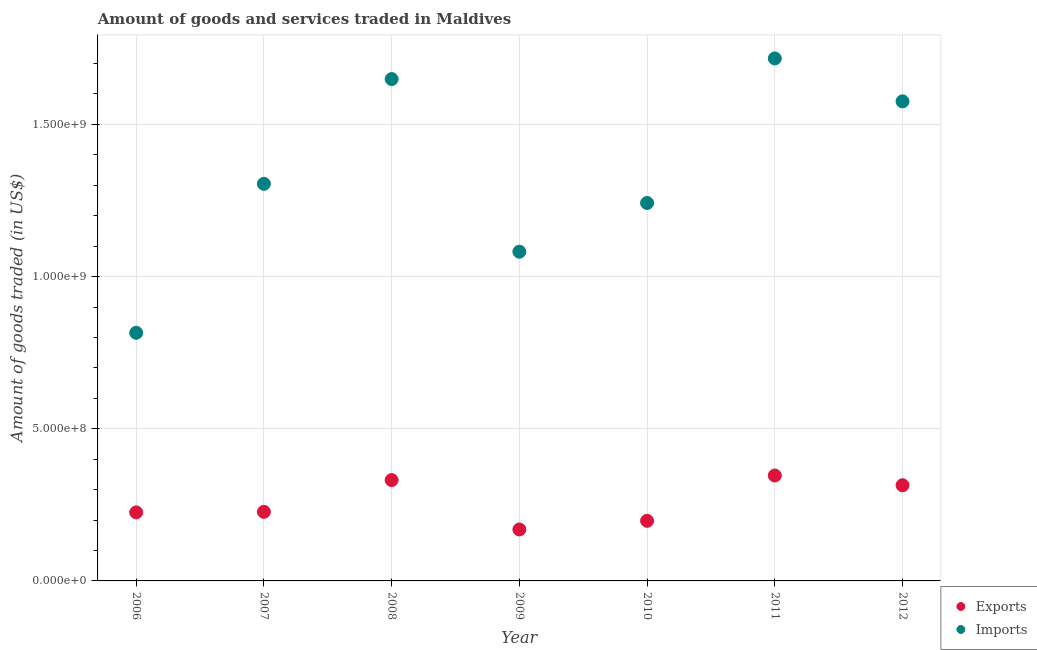How many different coloured dotlines are there?
Provide a short and direct response. 2. What is the amount of goods imported in 2009?
Provide a short and direct response. 1.08e+09. Across all years, what is the maximum amount of goods imported?
Make the answer very short. 1.72e+09. Across all years, what is the minimum amount of goods exported?
Offer a very short reply. 1.69e+08. In which year was the amount of goods imported minimum?
Your answer should be very brief. 2006. What is the total amount of goods imported in the graph?
Offer a very short reply. 9.39e+09. What is the difference between the amount of goods exported in 2006 and that in 2011?
Ensure brevity in your answer.  -1.21e+08. What is the difference between the amount of goods exported in 2010 and the amount of goods imported in 2008?
Ensure brevity in your answer.  -1.45e+09. What is the average amount of goods exported per year?
Your answer should be very brief. 2.59e+08. In the year 2007, what is the difference between the amount of goods exported and amount of goods imported?
Give a very brief answer. -1.08e+09. What is the ratio of the amount of goods imported in 2008 to that in 2012?
Give a very brief answer. 1.05. Is the amount of goods imported in 2007 less than that in 2010?
Ensure brevity in your answer.  No. Is the difference between the amount of goods imported in 2006 and 2008 greater than the difference between the amount of goods exported in 2006 and 2008?
Give a very brief answer. No. What is the difference between the highest and the second highest amount of goods exported?
Provide a short and direct response. 1.50e+07. What is the difference between the highest and the lowest amount of goods imported?
Ensure brevity in your answer.  9.01e+08. Is the sum of the amount of goods imported in 2006 and 2007 greater than the maximum amount of goods exported across all years?
Offer a terse response. Yes. Is the amount of goods imported strictly less than the amount of goods exported over the years?
Provide a short and direct response. No. How many dotlines are there?
Your response must be concise. 2. How many years are there in the graph?
Make the answer very short. 7. Are the values on the major ticks of Y-axis written in scientific E-notation?
Ensure brevity in your answer.  Yes. Does the graph contain any zero values?
Make the answer very short. No. Does the graph contain grids?
Your answer should be very brief. Yes. Where does the legend appear in the graph?
Your response must be concise. Bottom right. How many legend labels are there?
Your answer should be compact. 2. How are the legend labels stacked?
Offer a terse response. Vertical. What is the title of the graph?
Offer a terse response. Amount of goods and services traded in Maldives. Does "Male entrants" appear as one of the legend labels in the graph?
Offer a terse response. No. What is the label or title of the Y-axis?
Provide a short and direct response. Amount of goods traded (in US$). What is the Amount of goods traded (in US$) of Exports in 2006?
Provide a succinct answer. 2.25e+08. What is the Amount of goods traded (in US$) of Imports in 2006?
Make the answer very short. 8.15e+08. What is the Amount of goods traded (in US$) of Exports in 2007?
Your response must be concise. 2.27e+08. What is the Amount of goods traded (in US$) of Imports in 2007?
Give a very brief answer. 1.30e+09. What is the Amount of goods traded (in US$) in Exports in 2008?
Keep it short and to the point. 3.31e+08. What is the Amount of goods traded (in US$) of Imports in 2008?
Your answer should be compact. 1.65e+09. What is the Amount of goods traded (in US$) of Exports in 2009?
Provide a succinct answer. 1.69e+08. What is the Amount of goods traded (in US$) of Imports in 2009?
Offer a terse response. 1.08e+09. What is the Amount of goods traded (in US$) in Exports in 2010?
Provide a short and direct response. 1.98e+08. What is the Amount of goods traded (in US$) of Imports in 2010?
Ensure brevity in your answer.  1.24e+09. What is the Amount of goods traded (in US$) in Exports in 2011?
Your answer should be very brief. 3.46e+08. What is the Amount of goods traded (in US$) in Imports in 2011?
Provide a short and direct response. 1.72e+09. What is the Amount of goods traded (in US$) of Exports in 2012?
Provide a short and direct response. 3.14e+08. What is the Amount of goods traded (in US$) of Imports in 2012?
Provide a short and direct response. 1.58e+09. Across all years, what is the maximum Amount of goods traded (in US$) of Exports?
Keep it short and to the point. 3.46e+08. Across all years, what is the maximum Amount of goods traded (in US$) in Imports?
Provide a short and direct response. 1.72e+09. Across all years, what is the minimum Amount of goods traded (in US$) in Exports?
Your response must be concise. 1.69e+08. Across all years, what is the minimum Amount of goods traded (in US$) in Imports?
Ensure brevity in your answer.  8.15e+08. What is the total Amount of goods traded (in US$) in Exports in the graph?
Ensure brevity in your answer.  1.81e+09. What is the total Amount of goods traded (in US$) in Imports in the graph?
Your answer should be very brief. 9.39e+09. What is the difference between the Amount of goods traded (in US$) in Exports in 2006 and that in 2007?
Your answer should be very brief. -1.71e+06. What is the difference between the Amount of goods traded (in US$) in Imports in 2006 and that in 2007?
Your response must be concise. -4.89e+08. What is the difference between the Amount of goods traded (in US$) in Exports in 2006 and that in 2008?
Offer a very short reply. -1.06e+08. What is the difference between the Amount of goods traded (in US$) of Imports in 2006 and that in 2008?
Ensure brevity in your answer.  -8.34e+08. What is the difference between the Amount of goods traded (in US$) of Exports in 2006 and that in 2009?
Offer a very short reply. 5.62e+07. What is the difference between the Amount of goods traded (in US$) of Imports in 2006 and that in 2009?
Provide a short and direct response. -2.66e+08. What is the difference between the Amount of goods traded (in US$) of Exports in 2006 and that in 2010?
Offer a terse response. 2.77e+07. What is the difference between the Amount of goods traded (in US$) of Imports in 2006 and that in 2010?
Provide a succinct answer. -4.26e+08. What is the difference between the Amount of goods traded (in US$) of Exports in 2006 and that in 2011?
Keep it short and to the point. -1.21e+08. What is the difference between the Amount of goods traded (in US$) in Imports in 2006 and that in 2011?
Your answer should be compact. -9.01e+08. What is the difference between the Amount of goods traded (in US$) in Exports in 2006 and that in 2012?
Make the answer very short. -8.92e+07. What is the difference between the Amount of goods traded (in US$) of Imports in 2006 and that in 2012?
Provide a short and direct response. -7.60e+08. What is the difference between the Amount of goods traded (in US$) in Exports in 2007 and that in 2008?
Your response must be concise. -1.04e+08. What is the difference between the Amount of goods traded (in US$) in Imports in 2007 and that in 2008?
Your response must be concise. -3.44e+08. What is the difference between the Amount of goods traded (in US$) in Exports in 2007 and that in 2009?
Keep it short and to the point. 5.79e+07. What is the difference between the Amount of goods traded (in US$) in Imports in 2007 and that in 2009?
Offer a very short reply. 2.23e+08. What is the difference between the Amount of goods traded (in US$) in Exports in 2007 and that in 2010?
Offer a very short reply. 2.95e+07. What is the difference between the Amount of goods traded (in US$) in Imports in 2007 and that in 2010?
Offer a terse response. 6.30e+07. What is the difference between the Amount of goods traded (in US$) of Exports in 2007 and that in 2011?
Your answer should be compact. -1.19e+08. What is the difference between the Amount of goods traded (in US$) of Imports in 2007 and that in 2011?
Keep it short and to the point. -4.12e+08. What is the difference between the Amount of goods traded (in US$) in Exports in 2007 and that in 2012?
Your answer should be compact. -8.75e+07. What is the difference between the Amount of goods traded (in US$) in Imports in 2007 and that in 2012?
Your response must be concise. -2.71e+08. What is the difference between the Amount of goods traded (in US$) of Exports in 2008 and that in 2009?
Offer a terse response. 1.62e+08. What is the difference between the Amount of goods traded (in US$) of Imports in 2008 and that in 2009?
Give a very brief answer. 5.67e+08. What is the difference between the Amount of goods traded (in US$) in Exports in 2008 and that in 2010?
Offer a very short reply. 1.34e+08. What is the difference between the Amount of goods traded (in US$) of Imports in 2008 and that in 2010?
Give a very brief answer. 4.07e+08. What is the difference between the Amount of goods traded (in US$) of Exports in 2008 and that in 2011?
Offer a very short reply. -1.50e+07. What is the difference between the Amount of goods traded (in US$) in Imports in 2008 and that in 2011?
Provide a short and direct response. -6.78e+07. What is the difference between the Amount of goods traded (in US$) in Exports in 2008 and that in 2012?
Your answer should be compact. 1.70e+07. What is the difference between the Amount of goods traded (in US$) in Imports in 2008 and that in 2012?
Ensure brevity in your answer.  7.32e+07. What is the difference between the Amount of goods traded (in US$) in Exports in 2009 and that in 2010?
Ensure brevity in your answer.  -2.85e+07. What is the difference between the Amount of goods traded (in US$) of Imports in 2009 and that in 2010?
Make the answer very short. -1.60e+08. What is the difference between the Amount of goods traded (in US$) in Exports in 2009 and that in 2011?
Your answer should be very brief. -1.77e+08. What is the difference between the Amount of goods traded (in US$) of Imports in 2009 and that in 2011?
Give a very brief answer. -6.35e+08. What is the difference between the Amount of goods traded (in US$) in Exports in 2009 and that in 2012?
Offer a very short reply. -1.45e+08. What is the difference between the Amount of goods traded (in US$) in Imports in 2009 and that in 2012?
Keep it short and to the point. -4.94e+08. What is the difference between the Amount of goods traded (in US$) in Exports in 2010 and that in 2011?
Your answer should be very brief. -1.49e+08. What is the difference between the Amount of goods traded (in US$) of Imports in 2010 and that in 2011?
Offer a terse response. -4.75e+08. What is the difference between the Amount of goods traded (in US$) in Exports in 2010 and that in 2012?
Your answer should be compact. -1.17e+08. What is the difference between the Amount of goods traded (in US$) of Imports in 2010 and that in 2012?
Your answer should be compact. -3.34e+08. What is the difference between the Amount of goods traded (in US$) in Exports in 2011 and that in 2012?
Keep it short and to the point. 3.20e+07. What is the difference between the Amount of goods traded (in US$) in Imports in 2011 and that in 2012?
Offer a very short reply. 1.41e+08. What is the difference between the Amount of goods traded (in US$) of Exports in 2006 and the Amount of goods traded (in US$) of Imports in 2007?
Your answer should be very brief. -1.08e+09. What is the difference between the Amount of goods traded (in US$) of Exports in 2006 and the Amount of goods traded (in US$) of Imports in 2008?
Offer a terse response. -1.42e+09. What is the difference between the Amount of goods traded (in US$) of Exports in 2006 and the Amount of goods traded (in US$) of Imports in 2009?
Offer a very short reply. -8.56e+08. What is the difference between the Amount of goods traded (in US$) of Exports in 2006 and the Amount of goods traded (in US$) of Imports in 2010?
Your answer should be very brief. -1.02e+09. What is the difference between the Amount of goods traded (in US$) in Exports in 2006 and the Amount of goods traded (in US$) in Imports in 2011?
Make the answer very short. -1.49e+09. What is the difference between the Amount of goods traded (in US$) in Exports in 2006 and the Amount of goods traded (in US$) in Imports in 2012?
Your response must be concise. -1.35e+09. What is the difference between the Amount of goods traded (in US$) in Exports in 2007 and the Amount of goods traded (in US$) in Imports in 2008?
Give a very brief answer. -1.42e+09. What is the difference between the Amount of goods traded (in US$) in Exports in 2007 and the Amount of goods traded (in US$) in Imports in 2009?
Your answer should be very brief. -8.55e+08. What is the difference between the Amount of goods traded (in US$) in Exports in 2007 and the Amount of goods traded (in US$) in Imports in 2010?
Ensure brevity in your answer.  -1.01e+09. What is the difference between the Amount of goods traded (in US$) in Exports in 2007 and the Amount of goods traded (in US$) in Imports in 2011?
Your answer should be compact. -1.49e+09. What is the difference between the Amount of goods traded (in US$) of Exports in 2007 and the Amount of goods traded (in US$) of Imports in 2012?
Offer a very short reply. -1.35e+09. What is the difference between the Amount of goods traded (in US$) in Exports in 2008 and the Amount of goods traded (in US$) in Imports in 2009?
Keep it short and to the point. -7.50e+08. What is the difference between the Amount of goods traded (in US$) in Exports in 2008 and the Amount of goods traded (in US$) in Imports in 2010?
Ensure brevity in your answer.  -9.10e+08. What is the difference between the Amount of goods traded (in US$) of Exports in 2008 and the Amount of goods traded (in US$) of Imports in 2011?
Your answer should be compact. -1.39e+09. What is the difference between the Amount of goods traded (in US$) in Exports in 2008 and the Amount of goods traded (in US$) in Imports in 2012?
Keep it short and to the point. -1.24e+09. What is the difference between the Amount of goods traded (in US$) in Exports in 2009 and the Amount of goods traded (in US$) in Imports in 2010?
Ensure brevity in your answer.  -1.07e+09. What is the difference between the Amount of goods traded (in US$) of Exports in 2009 and the Amount of goods traded (in US$) of Imports in 2011?
Give a very brief answer. -1.55e+09. What is the difference between the Amount of goods traded (in US$) in Exports in 2009 and the Amount of goods traded (in US$) in Imports in 2012?
Give a very brief answer. -1.41e+09. What is the difference between the Amount of goods traded (in US$) of Exports in 2010 and the Amount of goods traded (in US$) of Imports in 2011?
Your response must be concise. -1.52e+09. What is the difference between the Amount of goods traded (in US$) of Exports in 2010 and the Amount of goods traded (in US$) of Imports in 2012?
Provide a succinct answer. -1.38e+09. What is the difference between the Amount of goods traded (in US$) of Exports in 2011 and the Amount of goods traded (in US$) of Imports in 2012?
Offer a terse response. -1.23e+09. What is the average Amount of goods traded (in US$) in Exports per year?
Offer a terse response. 2.59e+08. What is the average Amount of goods traded (in US$) in Imports per year?
Your answer should be compact. 1.34e+09. In the year 2006, what is the difference between the Amount of goods traded (in US$) of Exports and Amount of goods traded (in US$) of Imports?
Offer a very short reply. -5.90e+08. In the year 2007, what is the difference between the Amount of goods traded (in US$) in Exports and Amount of goods traded (in US$) in Imports?
Provide a succinct answer. -1.08e+09. In the year 2008, what is the difference between the Amount of goods traded (in US$) of Exports and Amount of goods traded (in US$) of Imports?
Offer a terse response. -1.32e+09. In the year 2009, what is the difference between the Amount of goods traded (in US$) in Exports and Amount of goods traded (in US$) in Imports?
Provide a succinct answer. -9.13e+08. In the year 2010, what is the difference between the Amount of goods traded (in US$) in Exports and Amount of goods traded (in US$) in Imports?
Provide a short and direct response. -1.04e+09. In the year 2011, what is the difference between the Amount of goods traded (in US$) in Exports and Amount of goods traded (in US$) in Imports?
Keep it short and to the point. -1.37e+09. In the year 2012, what is the difference between the Amount of goods traded (in US$) in Exports and Amount of goods traded (in US$) in Imports?
Offer a very short reply. -1.26e+09. What is the ratio of the Amount of goods traded (in US$) of Exports in 2006 to that in 2007?
Offer a terse response. 0.99. What is the ratio of the Amount of goods traded (in US$) of Imports in 2006 to that in 2007?
Offer a terse response. 0.62. What is the ratio of the Amount of goods traded (in US$) of Exports in 2006 to that in 2008?
Ensure brevity in your answer.  0.68. What is the ratio of the Amount of goods traded (in US$) of Imports in 2006 to that in 2008?
Make the answer very short. 0.49. What is the ratio of the Amount of goods traded (in US$) in Exports in 2006 to that in 2009?
Give a very brief answer. 1.33. What is the ratio of the Amount of goods traded (in US$) of Imports in 2006 to that in 2009?
Give a very brief answer. 0.75. What is the ratio of the Amount of goods traded (in US$) in Exports in 2006 to that in 2010?
Offer a terse response. 1.14. What is the ratio of the Amount of goods traded (in US$) in Imports in 2006 to that in 2010?
Your answer should be very brief. 0.66. What is the ratio of the Amount of goods traded (in US$) in Exports in 2006 to that in 2011?
Keep it short and to the point. 0.65. What is the ratio of the Amount of goods traded (in US$) in Imports in 2006 to that in 2011?
Give a very brief answer. 0.47. What is the ratio of the Amount of goods traded (in US$) of Exports in 2006 to that in 2012?
Give a very brief answer. 0.72. What is the ratio of the Amount of goods traded (in US$) in Imports in 2006 to that in 2012?
Your response must be concise. 0.52. What is the ratio of the Amount of goods traded (in US$) of Exports in 2007 to that in 2008?
Make the answer very short. 0.68. What is the ratio of the Amount of goods traded (in US$) of Imports in 2007 to that in 2008?
Ensure brevity in your answer.  0.79. What is the ratio of the Amount of goods traded (in US$) of Exports in 2007 to that in 2009?
Provide a short and direct response. 1.34. What is the ratio of the Amount of goods traded (in US$) of Imports in 2007 to that in 2009?
Offer a terse response. 1.21. What is the ratio of the Amount of goods traded (in US$) of Exports in 2007 to that in 2010?
Provide a succinct answer. 1.15. What is the ratio of the Amount of goods traded (in US$) in Imports in 2007 to that in 2010?
Offer a very short reply. 1.05. What is the ratio of the Amount of goods traded (in US$) of Exports in 2007 to that in 2011?
Ensure brevity in your answer.  0.66. What is the ratio of the Amount of goods traded (in US$) in Imports in 2007 to that in 2011?
Your answer should be very brief. 0.76. What is the ratio of the Amount of goods traded (in US$) in Exports in 2007 to that in 2012?
Your answer should be very brief. 0.72. What is the ratio of the Amount of goods traded (in US$) in Imports in 2007 to that in 2012?
Keep it short and to the point. 0.83. What is the ratio of the Amount of goods traded (in US$) in Exports in 2008 to that in 2009?
Offer a very short reply. 1.96. What is the ratio of the Amount of goods traded (in US$) of Imports in 2008 to that in 2009?
Your answer should be compact. 1.52. What is the ratio of the Amount of goods traded (in US$) of Exports in 2008 to that in 2010?
Ensure brevity in your answer.  1.68. What is the ratio of the Amount of goods traded (in US$) of Imports in 2008 to that in 2010?
Your answer should be compact. 1.33. What is the ratio of the Amount of goods traded (in US$) in Exports in 2008 to that in 2011?
Provide a short and direct response. 0.96. What is the ratio of the Amount of goods traded (in US$) in Imports in 2008 to that in 2011?
Offer a very short reply. 0.96. What is the ratio of the Amount of goods traded (in US$) in Exports in 2008 to that in 2012?
Make the answer very short. 1.05. What is the ratio of the Amount of goods traded (in US$) of Imports in 2008 to that in 2012?
Your answer should be very brief. 1.05. What is the ratio of the Amount of goods traded (in US$) in Exports in 2009 to that in 2010?
Keep it short and to the point. 0.86. What is the ratio of the Amount of goods traded (in US$) of Imports in 2009 to that in 2010?
Give a very brief answer. 0.87. What is the ratio of the Amount of goods traded (in US$) of Exports in 2009 to that in 2011?
Offer a very short reply. 0.49. What is the ratio of the Amount of goods traded (in US$) in Imports in 2009 to that in 2011?
Ensure brevity in your answer.  0.63. What is the ratio of the Amount of goods traded (in US$) in Exports in 2009 to that in 2012?
Your response must be concise. 0.54. What is the ratio of the Amount of goods traded (in US$) of Imports in 2009 to that in 2012?
Your response must be concise. 0.69. What is the ratio of the Amount of goods traded (in US$) of Exports in 2010 to that in 2011?
Ensure brevity in your answer.  0.57. What is the ratio of the Amount of goods traded (in US$) in Imports in 2010 to that in 2011?
Ensure brevity in your answer.  0.72. What is the ratio of the Amount of goods traded (in US$) of Exports in 2010 to that in 2012?
Offer a terse response. 0.63. What is the ratio of the Amount of goods traded (in US$) of Imports in 2010 to that in 2012?
Make the answer very short. 0.79. What is the ratio of the Amount of goods traded (in US$) of Exports in 2011 to that in 2012?
Keep it short and to the point. 1.1. What is the ratio of the Amount of goods traded (in US$) in Imports in 2011 to that in 2012?
Your response must be concise. 1.09. What is the difference between the highest and the second highest Amount of goods traded (in US$) of Exports?
Your answer should be very brief. 1.50e+07. What is the difference between the highest and the second highest Amount of goods traded (in US$) of Imports?
Offer a terse response. 6.78e+07. What is the difference between the highest and the lowest Amount of goods traded (in US$) in Exports?
Your answer should be very brief. 1.77e+08. What is the difference between the highest and the lowest Amount of goods traded (in US$) of Imports?
Provide a short and direct response. 9.01e+08. 